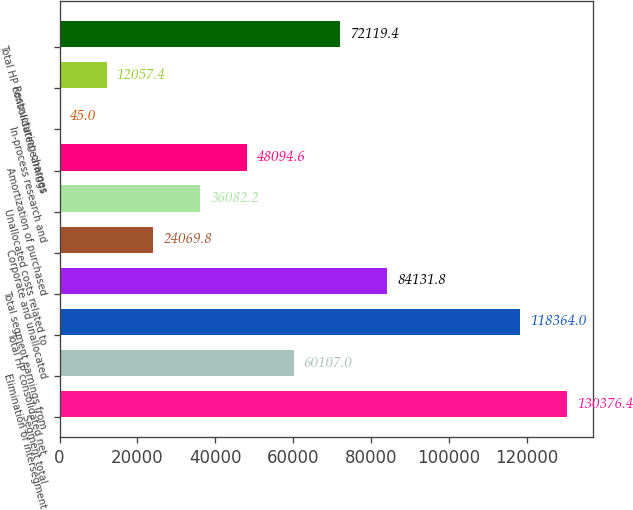Convert chart. <chart><loc_0><loc_0><loc_500><loc_500><bar_chart><fcel>Segment total<fcel>Elimination of intersegment<fcel>Total HP consolidated net<fcel>Total segment earnings from<fcel>Corporate and unallocated<fcel>Unallocated costs related to<fcel>Amortization of purchased<fcel>In-process research and<fcel>Restructuring charges<fcel>Total HP consolidated earnings<nl><fcel>130376<fcel>60107<fcel>118364<fcel>84131.8<fcel>24069.8<fcel>36082.2<fcel>48094.6<fcel>45<fcel>12057.4<fcel>72119.4<nl></chart> 